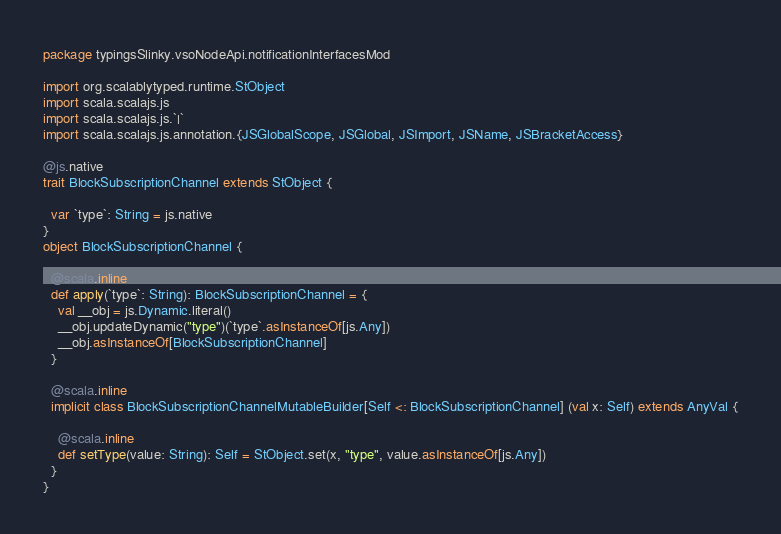<code> <loc_0><loc_0><loc_500><loc_500><_Scala_>package typingsSlinky.vsoNodeApi.notificationInterfacesMod

import org.scalablytyped.runtime.StObject
import scala.scalajs.js
import scala.scalajs.js.`|`
import scala.scalajs.js.annotation.{JSGlobalScope, JSGlobal, JSImport, JSName, JSBracketAccess}

@js.native
trait BlockSubscriptionChannel extends StObject {
  
  var `type`: String = js.native
}
object BlockSubscriptionChannel {
  
  @scala.inline
  def apply(`type`: String): BlockSubscriptionChannel = {
    val __obj = js.Dynamic.literal()
    __obj.updateDynamic("type")(`type`.asInstanceOf[js.Any])
    __obj.asInstanceOf[BlockSubscriptionChannel]
  }
  
  @scala.inline
  implicit class BlockSubscriptionChannelMutableBuilder[Self <: BlockSubscriptionChannel] (val x: Self) extends AnyVal {
    
    @scala.inline
    def setType(value: String): Self = StObject.set(x, "type", value.asInstanceOf[js.Any])
  }
}
</code> 